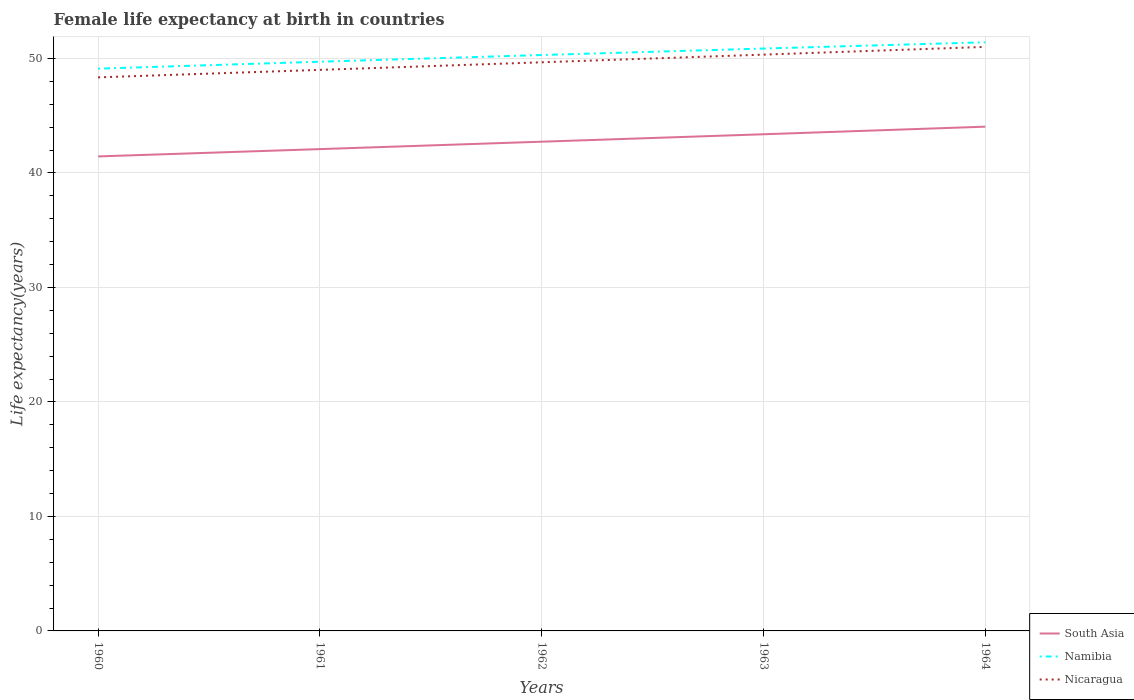How many different coloured lines are there?
Your answer should be compact. 3. Across all years, what is the maximum female life expectancy at birth in South Asia?
Your answer should be very brief. 41.44. What is the total female life expectancy at birth in South Asia in the graph?
Keep it short and to the point. -1.31. What is the difference between the highest and the second highest female life expectancy at birth in South Asia?
Give a very brief answer. 2.6. What is the difference between the highest and the lowest female life expectancy at birth in Nicaragua?
Offer a very short reply. 2. Is the female life expectancy at birth in South Asia strictly greater than the female life expectancy at birth in Nicaragua over the years?
Offer a very short reply. Yes. How many lines are there?
Offer a very short reply. 3. What is the difference between two consecutive major ticks on the Y-axis?
Offer a terse response. 10. Does the graph contain grids?
Offer a very short reply. Yes. Where does the legend appear in the graph?
Your answer should be very brief. Bottom right. What is the title of the graph?
Your answer should be compact. Female life expectancy at birth in countries. What is the label or title of the Y-axis?
Offer a terse response. Life expectancy(years). What is the Life expectancy(years) of South Asia in 1960?
Provide a short and direct response. 41.44. What is the Life expectancy(years) of Namibia in 1960?
Make the answer very short. 49.11. What is the Life expectancy(years) in Nicaragua in 1960?
Provide a short and direct response. 48.35. What is the Life expectancy(years) in South Asia in 1961?
Ensure brevity in your answer.  42.08. What is the Life expectancy(years) of Namibia in 1961?
Your response must be concise. 49.72. What is the Life expectancy(years) in Nicaragua in 1961?
Provide a short and direct response. 49. What is the Life expectancy(years) of South Asia in 1962?
Offer a terse response. 42.73. What is the Life expectancy(years) of Namibia in 1962?
Make the answer very short. 50.3. What is the Life expectancy(years) of Nicaragua in 1962?
Your response must be concise. 49.67. What is the Life expectancy(years) in South Asia in 1963?
Your answer should be compact. 43.38. What is the Life expectancy(years) of Namibia in 1963?
Provide a succinct answer. 50.87. What is the Life expectancy(years) of Nicaragua in 1963?
Make the answer very short. 50.34. What is the Life expectancy(years) of South Asia in 1964?
Make the answer very short. 44.04. What is the Life expectancy(years) in Namibia in 1964?
Make the answer very short. 51.41. What is the Life expectancy(years) of Nicaragua in 1964?
Offer a terse response. 51.01. Across all years, what is the maximum Life expectancy(years) of South Asia?
Offer a terse response. 44.04. Across all years, what is the maximum Life expectancy(years) in Namibia?
Provide a succinct answer. 51.41. Across all years, what is the maximum Life expectancy(years) in Nicaragua?
Offer a very short reply. 51.01. Across all years, what is the minimum Life expectancy(years) in South Asia?
Your answer should be very brief. 41.44. Across all years, what is the minimum Life expectancy(years) in Namibia?
Provide a succinct answer. 49.11. Across all years, what is the minimum Life expectancy(years) of Nicaragua?
Make the answer very short. 48.35. What is the total Life expectancy(years) of South Asia in the graph?
Your response must be concise. 213.68. What is the total Life expectancy(years) in Namibia in the graph?
Offer a terse response. 251.41. What is the total Life expectancy(years) of Nicaragua in the graph?
Ensure brevity in your answer.  248.37. What is the difference between the Life expectancy(years) in South Asia in 1960 and that in 1961?
Offer a terse response. -0.64. What is the difference between the Life expectancy(years) of Namibia in 1960 and that in 1961?
Provide a short and direct response. -0.61. What is the difference between the Life expectancy(years) of Nicaragua in 1960 and that in 1961?
Your response must be concise. -0.65. What is the difference between the Life expectancy(years) of South Asia in 1960 and that in 1962?
Give a very brief answer. -1.29. What is the difference between the Life expectancy(years) in Namibia in 1960 and that in 1962?
Your answer should be compact. -1.19. What is the difference between the Life expectancy(years) in Nicaragua in 1960 and that in 1962?
Your answer should be compact. -1.32. What is the difference between the Life expectancy(years) of South Asia in 1960 and that in 1963?
Provide a short and direct response. -1.94. What is the difference between the Life expectancy(years) in Namibia in 1960 and that in 1963?
Make the answer very short. -1.76. What is the difference between the Life expectancy(years) in Nicaragua in 1960 and that in 1963?
Offer a terse response. -1.99. What is the difference between the Life expectancy(years) of South Asia in 1960 and that in 1964?
Offer a very short reply. -2.6. What is the difference between the Life expectancy(years) of Namibia in 1960 and that in 1964?
Offer a terse response. -2.3. What is the difference between the Life expectancy(years) of Nicaragua in 1960 and that in 1964?
Your answer should be compact. -2.66. What is the difference between the Life expectancy(years) in South Asia in 1961 and that in 1962?
Provide a succinct answer. -0.65. What is the difference between the Life expectancy(years) in Namibia in 1961 and that in 1962?
Offer a very short reply. -0.58. What is the difference between the Life expectancy(years) of Nicaragua in 1961 and that in 1962?
Provide a short and direct response. -0.66. What is the difference between the Life expectancy(years) of South Asia in 1961 and that in 1963?
Your answer should be compact. -1.3. What is the difference between the Life expectancy(years) of Namibia in 1961 and that in 1963?
Your answer should be very brief. -1.15. What is the difference between the Life expectancy(years) in Nicaragua in 1961 and that in 1963?
Keep it short and to the point. -1.33. What is the difference between the Life expectancy(years) in South Asia in 1961 and that in 1964?
Offer a very short reply. -1.96. What is the difference between the Life expectancy(years) in Namibia in 1961 and that in 1964?
Ensure brevity in your answer.  -1.7. What is the difference between the Life expectancy(years) in Nicaragua in 1961 and that in 1964?
Offer a terse response. -2.01. What is the difference between the Life expectancy(years) of South Asia in 1962 and that in 1963?
Provide a succinct answer. -0.65. What is the difference between the Life expectancy(years) of Namibia in 1962 and that in 1963?
Your answer should be very brief. -0.56. What is the difference between the Life expectancy(years) of Nicaragua in 1962 and that in 1963?
Provide a succinct answer. -0.67. What is the difference between the Life expectancy(years) of South Asia in 1962 and that in 1964?
Offer a terse response. -1.31. What is the difference between the Life expectancy(years) of Namibia in 1962 and that in 1964?
Offer a terse response. -1.11. What is the difference between the Life expectancy(years) in Nicaragua in 1962 and that in 1964?
Your answer should be very brief. -1.35. What is the difference between the Life expectancy(years) of South Asia in 1963 and that in 1964?
Make the answer very short. -0.66. What is the difference between the Life expectancy(years) in Namibia in 1963 and that in 1964?
Offer a very short reply. -0.55. What is the difference between the Life expectancy(years) in Nicaragua in 1963 and that in 1964?
Keep it short and to the point. -0.68. What is the difference between the Life expectancy(years) of South Asia in 1960 and the Life expectancy(years) of Namibia in 1961?
Give a very brief answer. -8.27. What is the difference between the Life expectancy(years) of South Asia in 1960 and the Life expectancy(years) of Nicaragua in 1961?
Offer a very short reply. -7.56. What is the difference between the Life expectancy(years) in Namibia in 1960 and the Life expectancy(years) in Nicaragua in 1961?
Your answer should be compact. 0.11. What is the difference between the Life expectancy(years) of South Asia in 1960 and the Life expectancy(years) of Namibia in 1962?
Make the answer very short. -8.86. What is the difference between the Life expectancy(years) in South Asia in 1960 and the Life expectancy(years) in Nicaragua in 1962?
Ensure brevity in your answer.  -8.22. What is the difference between the Life expectancy(years) of Namibia in 1960 and the Life expectancy(years) of Nicaragua in 1962?
Offer a terse response. -0.56. What is the difference between the Life expectancy(years) in South Asia in 1960 and the Life expectancy(years) in Namibia in 1963?
Offer a very short reply. -9.42. What is the difference between the Life expectancy(years) of South Asia in 1960 and the Life expectancy(years) of Nicaragua in 1963?
Your response must be concise. -8.89. What is the difference between the Life expectancy(years) of Namibia in 1960 and the Life expectancy(years) of Nicaragua in 1963?
Offer a terse response. -1.23. What is the difference between the Life expectancy(years) of South Asia in 1960 and the Life expectancy(years) of Namibia in 1964?
Give a very brief answer. -9.97. What is the difference between the Life expectancy(years) of South Asia in 1960 and the Life expectancy(years) of Nicaragua in 1964?
Your answer should be very brief. -9.57. What is the difference between the Life expectancy(years) in Namibia in 1960 and the Life expectancy(years) in Nicaragua in 1964?
Offer a very short reply. -1.9. What is the difference between the Life expectancy(years) of South Asia in 1961 and the Life expectancy(years) of Namibia in 1962?
Your answer should be very brief. -8.22. What is the difference between the Life expectancy(years) of South Asia in 1961 and the Life expectancy(years) of Nicaragua in 1962?
Make the answer very short. -7.58. What is the difference between the Life expectancy(years) in Namibia in 1961 and the Life expectancy(years) in Nicaragua in 1962?
Give a very brief answer. 0.05. What is the difference between the Life expectancy(years) of South Asia in 1961 and the Life expectancy(years) of Namibia in 1963?
Offer a terse response. -8.78. What is the difference between the Life expectancy(years) in South Asia in 1961 and the Life expectancy(years) in Nicaragua in 1963?
Make the answer very short. -8.25. What is the difference between the Life expectancy(years) of Namibia in 1961 and the Life expectancy(years) of Nicaragua in 1963?
Provide a short and direct response. -0.62. What is the difference between the Life expectancy(years) in South Asia in 1961 and the Life expectancy(years) in Namibia in 1964?
Your answer should be very brief. -9.33. What is the difference between the Life expectancy(years) in South Asia in 1961 and the Life expectancy(years) in Nicaragua in 1964?
Ensure brevity in your answer.  -8.93. What is the difference between the Life expectancy(years) in Namibia in 1961 and the Life expectancy(years) in Nicaragua in 1964?
Ensure brevity in your answer.  -1.29. What is the difference between the Life expectancy(years) of South Asia in 1962 and the Life expectancy(years) of Namibia in 1963?
Ensure brevity in your answer.  -8.14. What is the difference between the Life expectancy(years) in South Asia in 1962 and the Life expectancy(years) in Nicaragua in 1963?
Provide a short and direct response. -7.61. What is the difference between the Life expectancy(years) of Namibia in 1962 and the Life expectancy(years) of Nicaragua in 1963?
Your answer should be very brief. -0.03. What is the difference between the Life expectancy(years) of South Asia in 1962 and the Life expectancy(years) of Namibia in 1964?
Provide a short and direct response. -8.68. What is the difference between the Life expectancy(years) in South Asia in 1962 and the Life expectancy(years) in Nicaragua in 1964?
Provide a short and direct response. -8.28. What is the difference between the Life expectancy(years) in Namibia in 1962 and the Life expectancy(years) in Nicaragua in 1964?
Keep it short and to the point. -0.71. What is the difference between the Life expectancy(years) of South Asia in 1963 and the Life expectancy(years) of Namibia in 1964?
Provide a short and direct response. -8.03. What is the difference between the Life expectancy(years) in South Asia in 1963 and the Life expectancy(years) in Nicaragua in 1964?
Your answer should be very brief. -7.63. What is the difference between the Life expectancy(years) of Namibia in 1963 and the Life expectancy(years) of Nicaragua in 1964?
Your answer should be compact. -0.14. What is the average Life expectancy(years) of South Asia per year?
Provide a short and direct response. 42.74. What is the average Life expectancy(years) in Namibia per year?
Your answer should be very brief. 50.28. What is the average Life expectancy(years) in Nicaragua per year?
Provide a succinct answer. 49.67. In the year 1960, what is the difference between the Life expectancy(years) of South Asia and Life expectancy(years) of Namibia?
Your response must be concise. -7.67. In the year 1960, what is the difference between the Life expectancy(years) in South Asia and Life expectancy(years) in Nicaragua?
Provide a succinct answer. -6.91. In the year 1960, what is the difference between the Life expectancy(years) in Namibia and Life expectancy(years) in Nicaragua?
Your response must be concise. 0.76. In the year 1961, what is the difference between the Life expectancy(years) in South Asia and Life expectancy(years) in Namibia?
Offer a very short reply. -7.63. In the year 1961, what is the difference between the Life expectancy(years) in South Asia and Life expectancy(years) in Nicaragua?
Make the answer very short. -6.92. In the year 1961, what is the difference between the Life expectancy(years) of Namibia and Life expectancy(years) of Nicaragua?
Your response must be concise. 0.71. In the year 1962, what is the difference between the Life expectancy(years) in South Asia and Life expectancy(years) in Namibia?
Keep it short and to the point. -7.57. In the year 1962, what is the difference between the Life expectancy(years) in South Asia and Life expectancy(years) in Nicaragua?
Keep it short and to the point. -6.94. In the year 1962, what is the difference between the Life expectancy(years) of Namibia and Life expectancy(years) of Nicaragua?
Keep it short and to the point. 0.64. In the year 1963, what is the difference between the Life expectancy(years) of South Asia and Life expectancy(years) of Namibia?
Offer a terse response. -7.49. In the year 1963, what is the difference between the Life expectancy(years) in South Asia and Life expectancy(years) in Nicaragua?
Make the answer very short. -6.96. In the year 1963, what is the difference between the Life expectancy(years) in Namibia and Life expectancy(years) in Nicaragua?
Your answer should be compact. 0.53. In the year 1964, what is the difference between the Life expectancy(years) of South Asia and Life expectancy(years) of Namibia?
Your answer should be compact. -7.37. In the year 1964, what is the difference between the Life expectancy(years) in South Asia and Life expectancy(years) in Nicaragua?
Your answer should be very brief. -6.97. In the year 1964, what is the difference between the Life expectancy(years) of Namibia and Life expectancy(years) of Nicaragua?
Ensure brevity in your answer.  0.4. What is the ratio of the Life expectancy(years) of South Asia in 1960 to that in 1961?
Offer a very short reply. 0.98. What is the ratio of the Life expectancy(years) of Namibia in 1960 to that in 1961?
Make the answer very short. 0.99. What is the ratio of the Life expectancy(years) of Nicaragua in 1960 to that in 1961?
Offer a very short reply. 0.99. What is the ratio of the Life expectancy(years) in South Asia in 1960 to that in 1962?
Ensure brevity in your answer.  0.97. What is the ratio of the Life expectancy(years) in Namibia in 1960 to that in 1962?
Your answer should be very brief. 0.98. What is the ratio of the Life expectancy(years) of Nicaragua in 1960 to that in 1962?
Your answer should be very brief. 0.97. What is the ratio of the Life expectancy(years) in South Asia in 1960 to that in 1963?
Provide a succinct answer. 0.96. What is the ratio of the Life expectancy(years) of Namibia in 1960 to that in 1963?
Provide a succinct answer. 0.97. What is the ratio of the Life expectancy(years) in Nicaragua in 1960 to that in 1963?
Offer a terse response. 0.96. What is the ratio of the Life expectancy(years) of South Asia in 1960 to that in 1964?
Your response must be concise. 0.94. What is the ratio of the Life expectancy(years) in Namibia in 1960 to that in 1964?
Give a very brief answer. 0.96. What is the ratio of the Life expectancy(years) of Nicaragua in 1960 to that in 1964?
Offer a very short reply. 0.95. What is the ratio of the Life expectancy(years) of South Asia in 1961 to that in 1962?
Provide a succinct answer. 0.98. What is the ratio of the Life expectancy(years) of Namibia in 1961 to that in 1962?
Make the answer very short. 0.99. What is the ratio of the Life expectancy(years) in Nicaragua in 1961 to that in 1962?
Make the answer very short. 0.99. What is the ratio of the Life expectancy(years) of South Asia in 1961 to that in 1963?
Your response must be concise. 0.97. What is the ratio of the Life expectancy(years) in Namibia in 1961 to that in 1963?
Ensure brevity in your answer.  0.98. What is the ratio of the Life expectancy(years) in Nicaragua in 1961 to that in 1963?
Keep it short and to the point. 0.97. What is the ratio of the Life expectancy(years) in South Asia in 1961 to that in 1964?
Provide a short and direct response. 0.96. What is the ratio of the Life expectancy(years) of Nicaragua in 1961 to that in 1964?
Offer a terse response. 0.96. What is the ratio of the Life expectancy(years) in South Asia in 1962 to that in 1963?
Offer a terse response. 0.98. What is the ratio of the Life expectancy(years) of Namibia in 1962 to that in 1963?
Keep it short and to the point. 0.99. What is the ratio of the Life expectancy(years) of Nicaragua in 1962 to that in 1963?
Your answer should be very brief. 0.99. What is the ratio of the Life expectancy(years) in South Asia in 1962 to that in 1964?
Provide a short and direct response. 0.97. What is the ratio of the Life expectancy(years) of Namibia in 1962 to that in 1964?
Provide a short and direct response. 0.98. What is the ratio of the Life expectancy(years) in Nicaragua in 1962 to that in 1964?
Your answer should be very brief. 0.97. What is the ratio of the Life expectancy(years) of Nicaragua in 1963 to that in 1964?
Ensure brevity in your answer.  0.99. What is the difference between the highest and the second highest Life expectancy(years) in South Asia?
Keep it short and to the point. 0.66. What is the difference between the highest and the second highest Life expectancy(years) in Namibia?
Make the answer very short. 0.55. What is the difference between the highest and the second highest Life expectancy(years) in Nicaragua?
Give a very brief answer. 0.68. What is the difference between the highest and the lowest Life expectancy(years) in South Asia?
Keep it short and to the point. 2.6. What is the difference between the highest and the lowest Life expectancy(years) in Namibia?
Ensure brevity in your answer.  2.3. What is the difference between the highest and the lowest Life expectancy(years) in Nicaragua?
Provide a short and direct response. 2.66. 